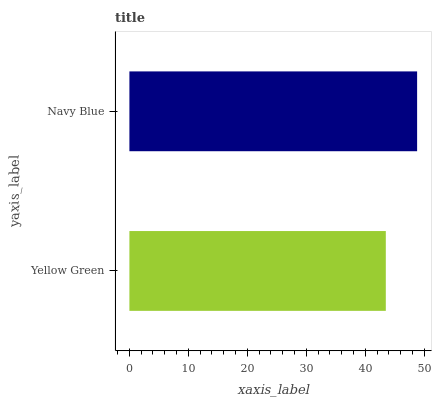Is Yellow Green the minimum?
Answer yes or no. Yes. Is Navy Blue the maximum?
Answer yes or no. Yes. Is Navy Blue the minimum?
Answer yes or no. No. Is Navy Blue greater than Yellow Green?
Answer yes or no. Yes. Is Yellow Green less than Navy Blue?
Answer yes or no. Yes. Is Yellow Green greater than Navy Blue?
Answer yes or no. No. Is Navy Blue less than Yellow Green?
Answer yes or no. No. Is Navy Blue the high median?
Answer yes or no. Yes. Is Yellow Green the low median?
Answer yes or no. Yes. Is Yellow Green the high median?
Answer yes or no. No. Is Navy Blue the low median?
Answer yes or no. No. 